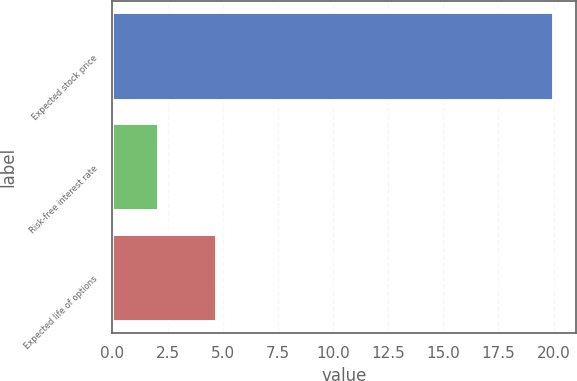Convert chart to OTSL. <chart><loc_0><loc_0><loc_500><loc_500><bar_chart><fcel>Expected stock price<fcel>Risk-free interest rate<fcel>Expected life of options<nl><fcel>20<fcel>2.13<fcel>4.75<nl></chart> 